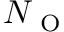<formula> <loc_0><loc_0><loc_500><loc_500>N _ { O }</formula> 